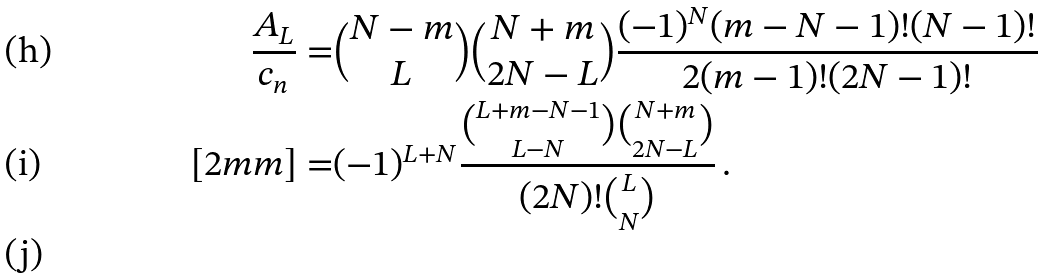<formula> <loc_0><loc_0><loc_500><loc_500>\frac { A _ { L } } { c _ { n } } = & { N - m \choose L } { N + m \choose 2 N - L } \frac { ( - 1 ) ^ { N } ( m - N - 1 ) ! ( N - 1 ) ! } { 2 ( m - 1 ) ! ( 2 N - 1 ) ! } \\ [ 2 m m ] = & ( - 1 ) ^ { L + N } \frac { { L + m - N - 1 \choose L - N } { N + m \choose 2 N - L } } { ( 2 N ) ! { L \choose N } } \, . \\</formula> 